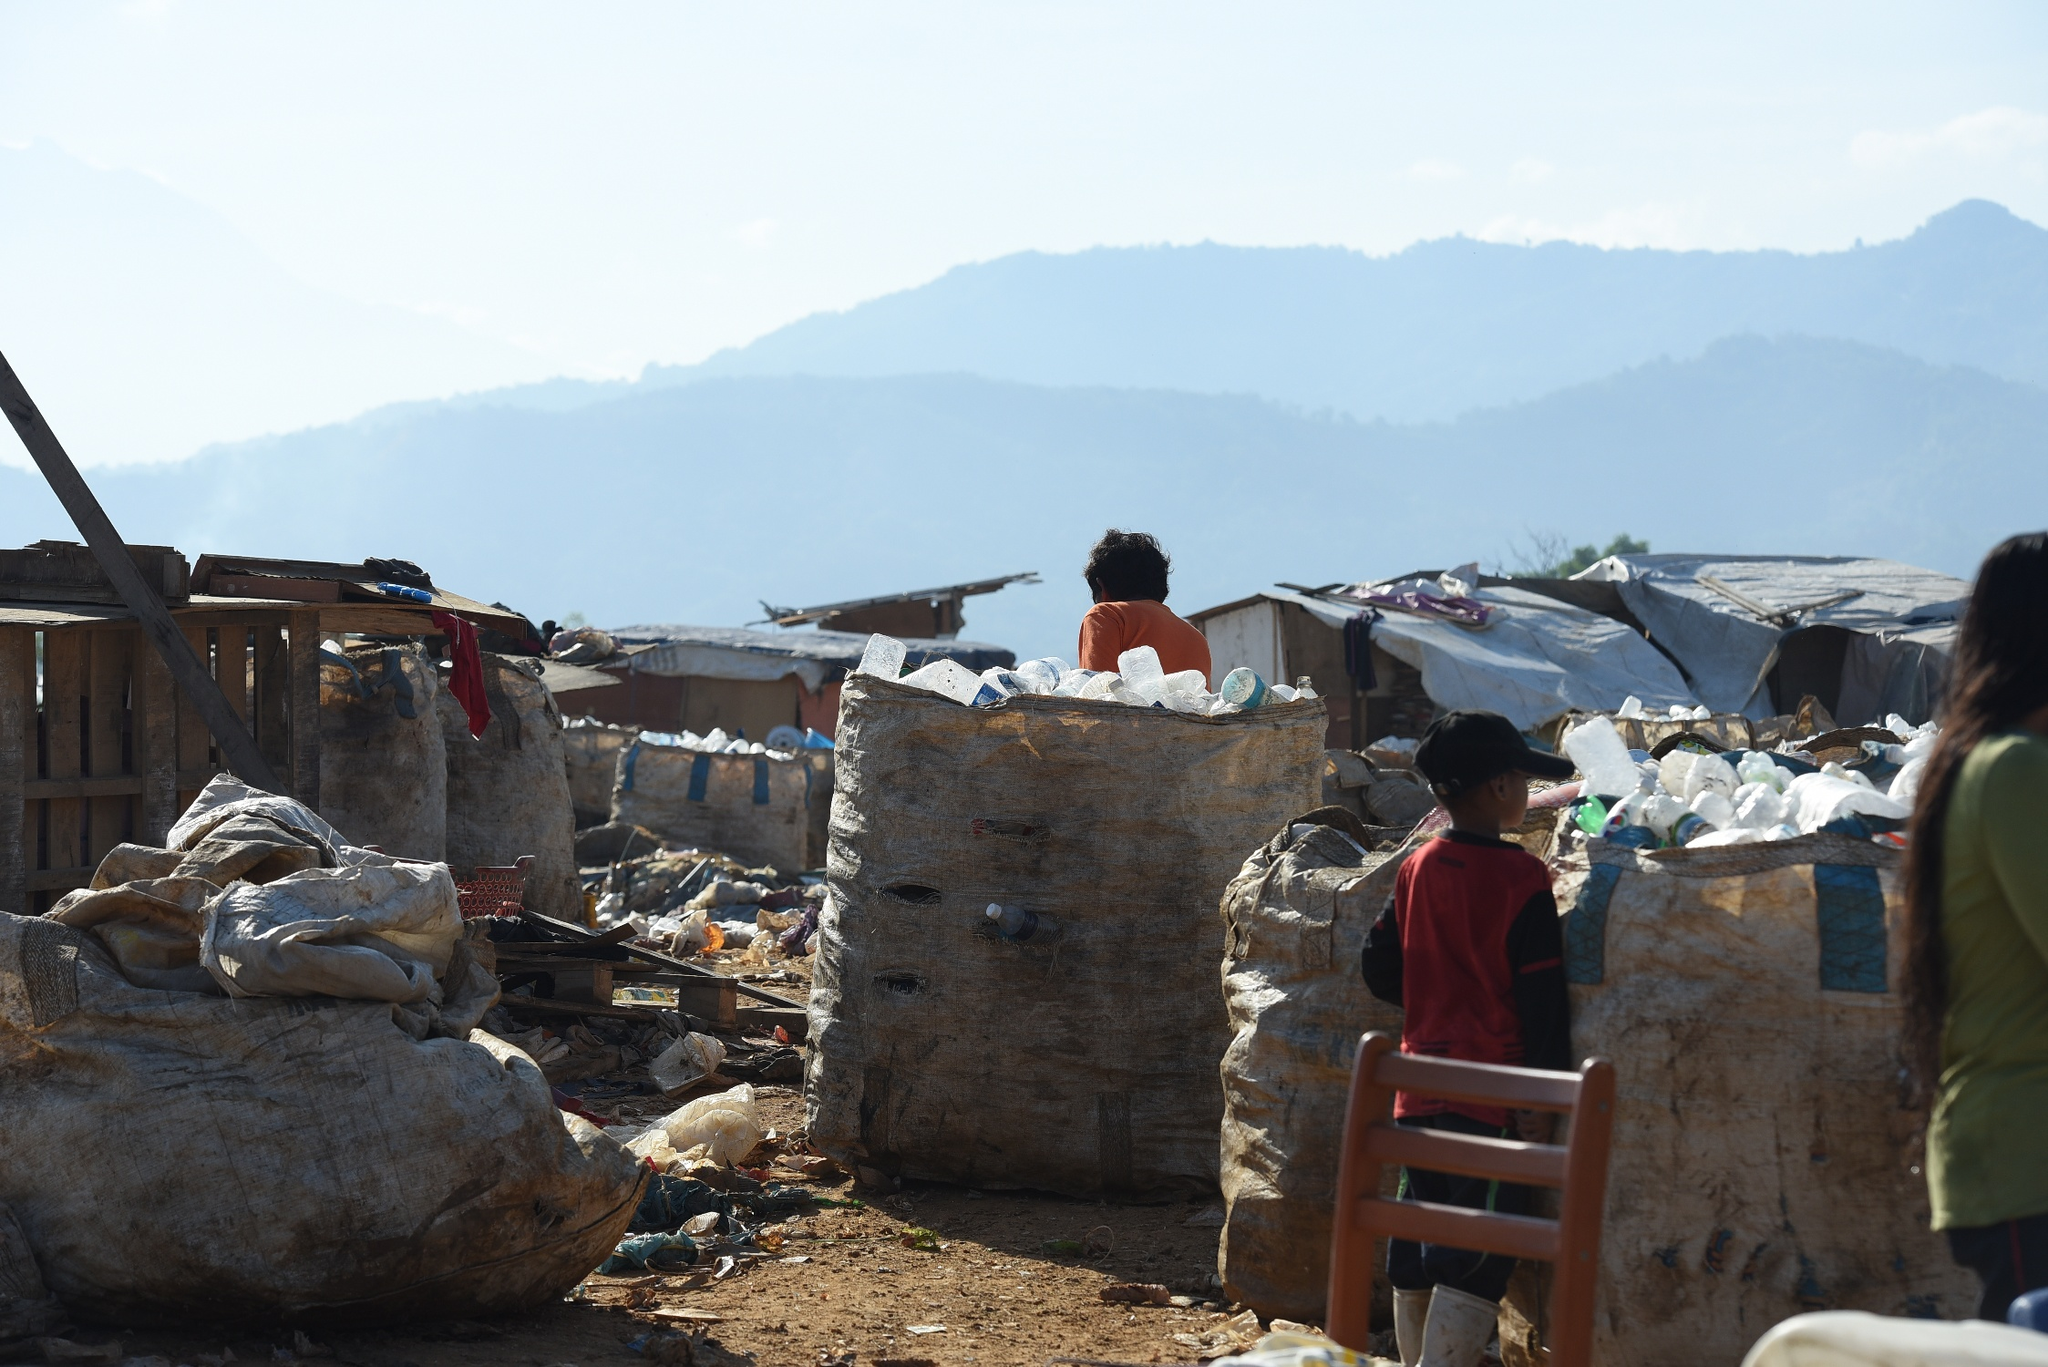How might the child feel standing next to all that garbage? The child standing next to the heaps of garbage may feel a mixture of confusion, concern, and sadness. The stark contrast between the innocence of youth and the overwhelming evidence of environmental degradation could evoke a sense of helplessness. Additionally, the child's expression and body language could provide further insight into their emotional state, whether they are used to the scene or find it disturbing. 